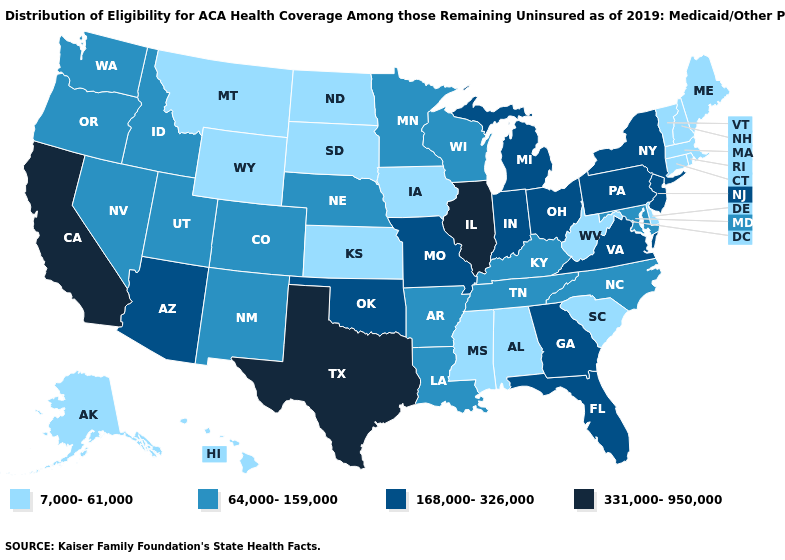What is the value of West Virginia?
Keep it brief. 7,000-61,000. Which states have the lowest value in the Northeast?
Concise answer only. Connecticut, Maine, Massachusetts, New Hampshire, Rhode Island, Vermont. What is the lowest value in states that border California?
Write a very short answer. 64,000-159,000. Among the states that border Connecticut , does New York have the highest value?
Short answer required. Yes. Which states hav the highest value in the South?
Keep it brief. Texas. Which states hav the highest value in the MidWest?
Give a very brief answer. Illinois. What is the value of Hawaii?
Short answer required. 7,000-61,000. Does Illinois have the highest value in the USA?
Short answer required. Yes. How many symbols are there in the legend?
Answer briefly. 4. What is the value of West Virginia?
Concise answer only. 7,000-61,000. Does Hawaii have the lowest value in the West?
Answer briefly. Yes. Among the states that border South Carolina , which have the highest value?
Keep it brief. Georgia. Name the states that have a value in the range 331,000-950,000?
Short answer required. California, Illinois, Texas. Which states have the highest value in the USA?
Give a very brief answer. California, Illinois, Texas. What is the value of Louisiana?
Keep it brief. 64,000-159,000. 